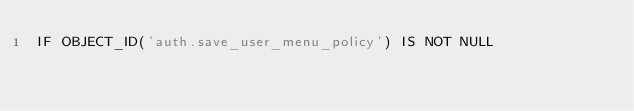Convert code to text. <code><loc_0><loc_0><loc_500><loc_500><_SQL_>IF OBJECT_ID('auth.save_user_menu_policy') IS NOT NULL</code> 